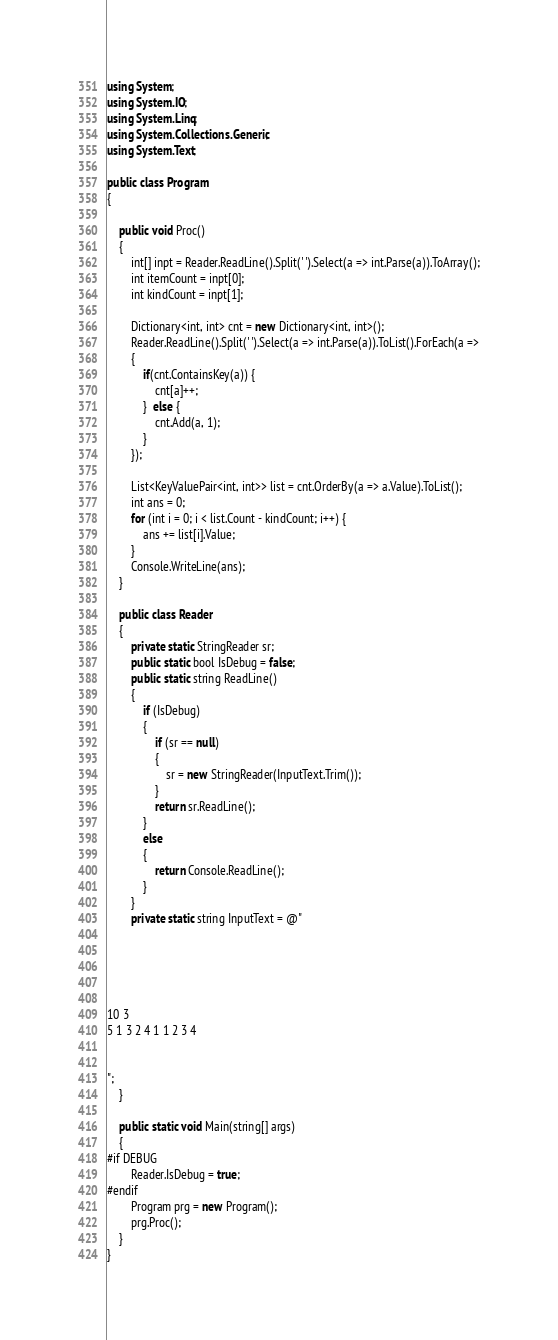<code> <loc_0><loc_0><loc_500><loc_500><_C#_>using System;
using System.IO;
using System.Linq;
using System.Collections.Generic;
using System.Text;

public class Program
{

    public void Proc()
    {
        int[] inpt = Reader.ReadLine().Split(' ').Select(a => int.Parse(a)).ToArray();
        int itemCount = inpt[0];
        int kindCount = inpt[1];

        Dictionary<int, int> cnt = new Dictionary<int, int>();
        Reader.ReadLine().Split(' ').Select(a => int.Parse(a)).ToList().ForEach(a =>
        {
            if(cnt.ContainsKey(a)) {
                cnt[a]++;
            }  else {
                cnt.Add(a, 1);
            }
        });

        List<KeyValuePair<int, int>> list = cnt.OrderBy(a => a.Value).ToList();
        int ans = 0;
        for (int i = 0; i < list.Count - kindCount; i++) {
            ans += list[i].Value;
        }
        Console.WriteLine(ans);
    }

    public class Reader
    {
        private static StringReader sr;
        public static bool IsDebug = false;
        public static string ReadLine()
        {
            if (IsDebug)
            {
                if (sr == null)
                {
                    sr = new StringReader(InputText.Trim());
                }
                return sr.ReadLine();
            }
            else
            {
                return Console.ReadLine();
            }
        }
        private static string InputText = @"





10 3
5 1 3 2 4 1 1 2 3 4


";
    }

    public static void Main(string[] args)
    {
#if DEBUG
        Reader.IsDebug = true;
#endif
        Program prg = new Program();
        prg.Proc();
    }
}
</code> 